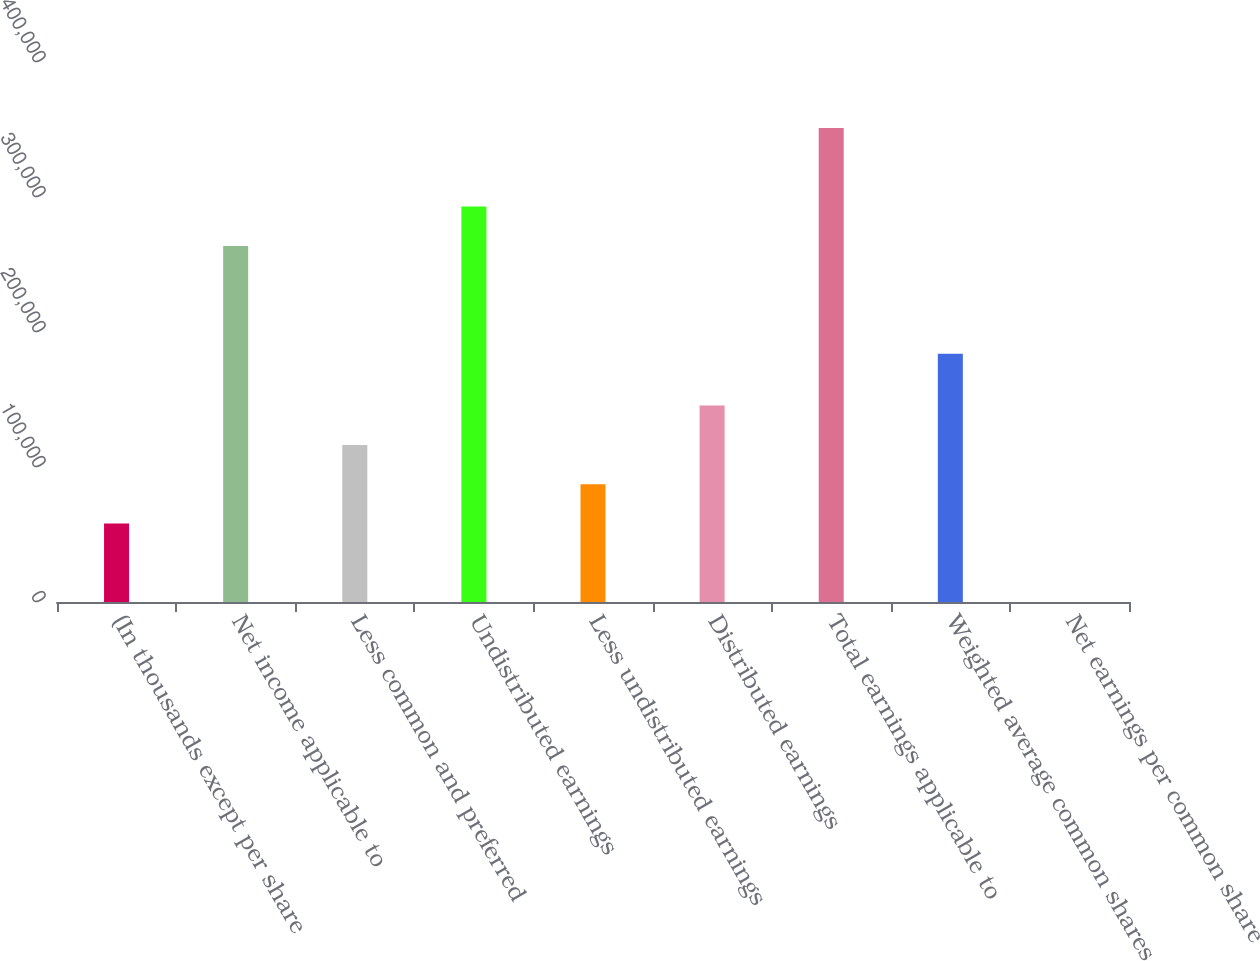Convert chart to OTSL. <chart><loc_0><loc_0><loc_500><loc_500><bar_chart><fcel>(In thousands except per share<fcel>Net income applicable to<fcel>Less common and preferred<fcel>Undistributed earnings<fcel>Less undistributed earnings<fcel>Distributed earnings<fcel>Total earnings applicable to<fcel>Weighted average common shares<fcel>Net earnings per common share<nl><fcel>58195.1<fcel>263791<fcel>116389<fcel>292888<fcel>87291.8<fcel>145485<fcel>351081<fcel>183844<fcel>1.58<nl></chart> 